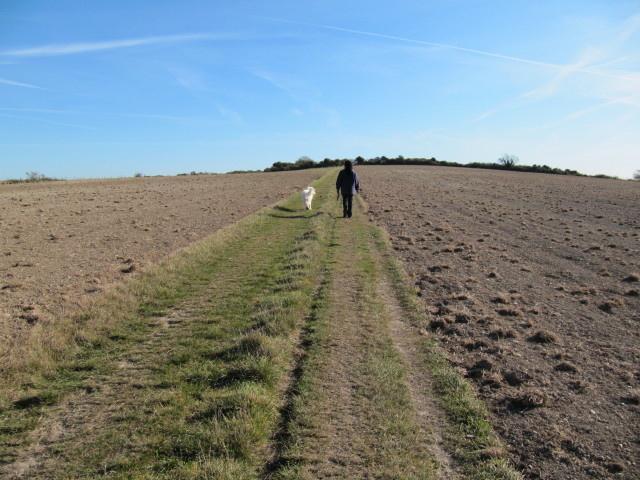How many people are pictured?
Give a very brief answer. 1. 